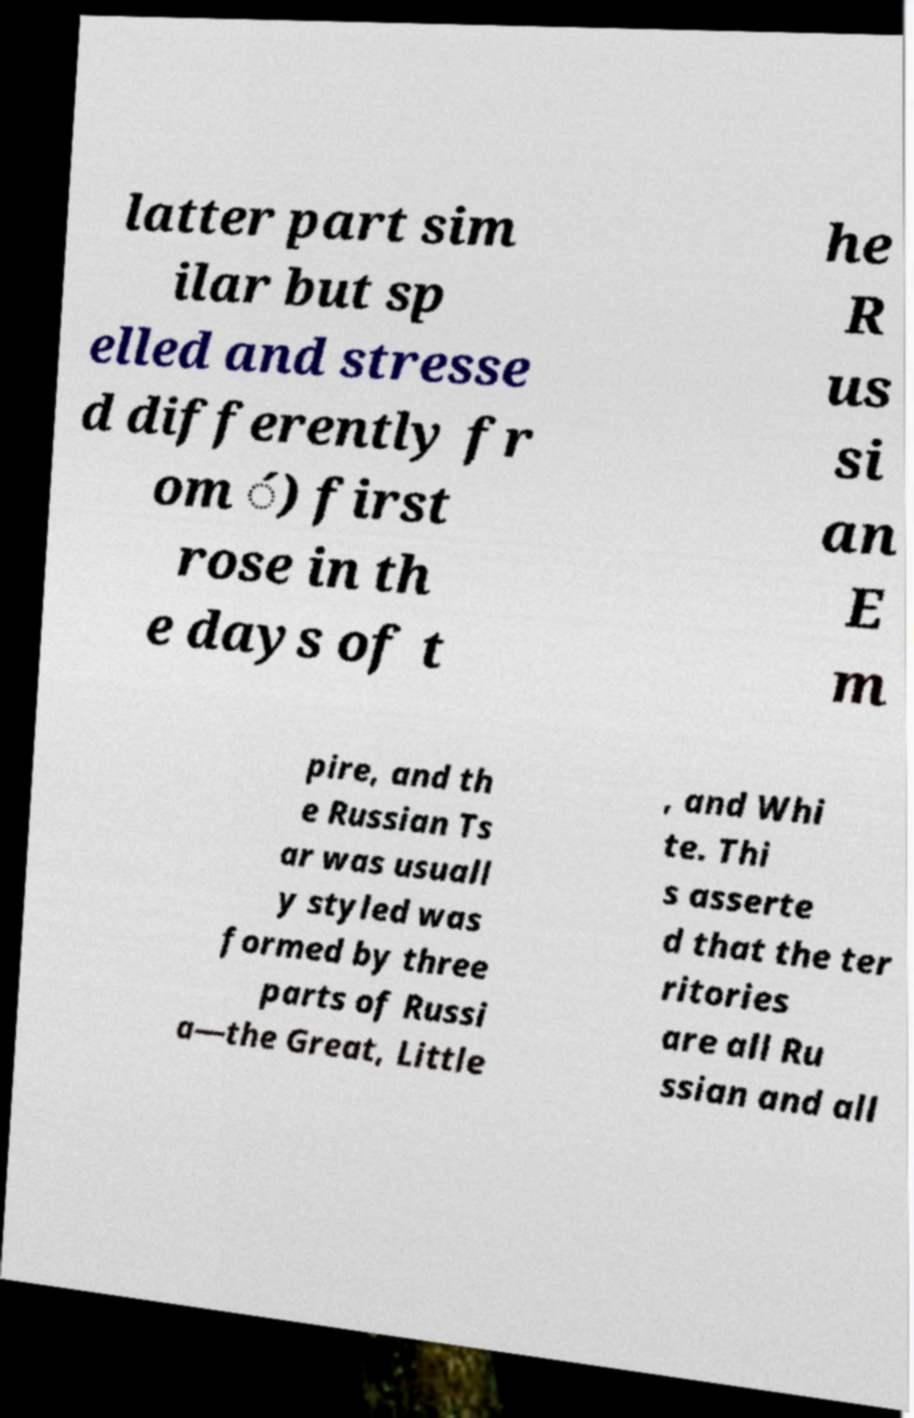Could you assist in decoding the text presented in this image and type it out clearly? latter part sim ilar but sp elled and stresse d differently fr om ́) first rose in th e days of t he R us si an E m pire, and th e Russian Ts ar was usuall y styled was formed by three parts of Russi a—the Great, Little , and Whi te. Thi s asserte d that the ter ritories are all Ru ssian and all 